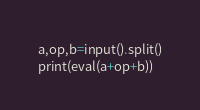Convert code to text. <code><loc_0><loc_0><loc_500><loc_500><_Python_>a,op,b=input().split()
print(eval(a+op+b))</code> 